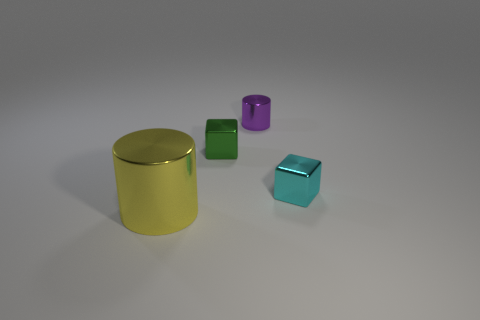There is a cyan metallic thing; is its size the same as the cylinder that is right of the yellow shiny cylinder?
Provide a short and direct response. Yes. There is a shiny cylinder behind the cylinder that is in front of the tiny purple object; what is its color?
Your response must be concise. Purple. Is the purple shiny cylinder the same size as the green object?
Keep it short and to the point. Yes. What color is the tiny object that is in front of the small purple cylinder and behind the small cyan block?
Your answer should be compact. Green. The yellow metallic cylinder has what size?
Your response must be concise. Large. There is a metal thing in front of the cyan object; is it the same color as the small metallic cylinder?
Provide a succinct answer. No. Are there more small green cubes that are in front of the large metallic object than purple shiny cylinders in front of the tiny purple metal thing?
Your answer should be compact. No. Are there more purple metal spheres than small purple cylinders?
Ensure brevity in your answer.  No. There is a metallic thing that is right of the green cube and in front of the green metal cube; what size is it?
Offer a terse response. Small. What is the shape of the small purple thing?
Your response must be concise. Cylinder. 